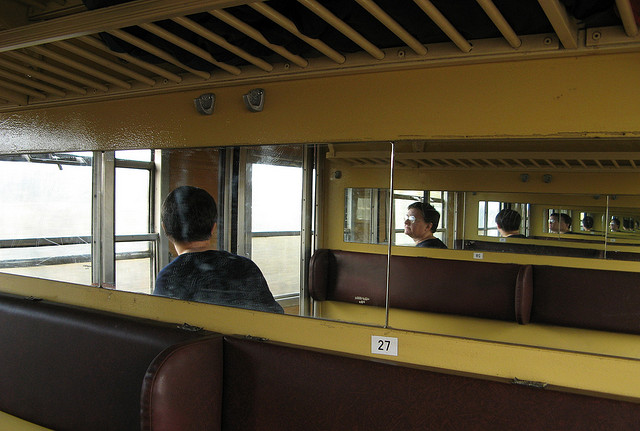Please transcribe the text in this image. 27 